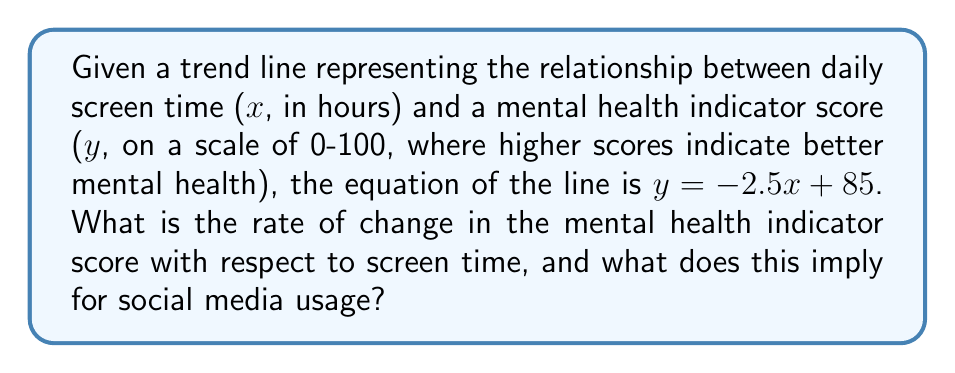What is the answer to this math problem? To analyze the slope of the trend line and its implications, we'll follow these steps:

1) The equation of the line is given as $y = -2.5x + 85$, where:
   $y$ is the mental health indicator score
   $x$ is the daily screen time in hours

2) In a linear equation of the form $y = mx + b$, the coefficient $m$ represents the slope of the line, which is also the rate of change of $y$ with respect to $x$.

3) In this case, $m = -2.5$. This means:
   $$\frac{dy}{dx} = -2.5$$

4) Interpretation:
   - The negative sign indicates an inverse relationship between screen time and mental health score.
   - For every 1-hour increase in daily screen time, the mental health indicator score decreases by 2.5 points.

5) Implications for social media usage:
   - Increased screen time, which often correlates with higher social media usage, is associated with a decline in mental health indicators.
   - The rate of decline (-2.5 points per hour) suggests a significant negative impact of prolonged screen time on mental health.

6) For a social media analyst concerned with ethical implications:
   - This data suggests that platforms should consider implementing features to encourage mindful usage and limit excessive screen time.
   - There may be a need for more robust mental health support systems integrated into social media platforms.
   - Further research into the causality of this relationship and potential mitigating factors would be valuable.
Answer: $-2.5$ points per hour of screen time 